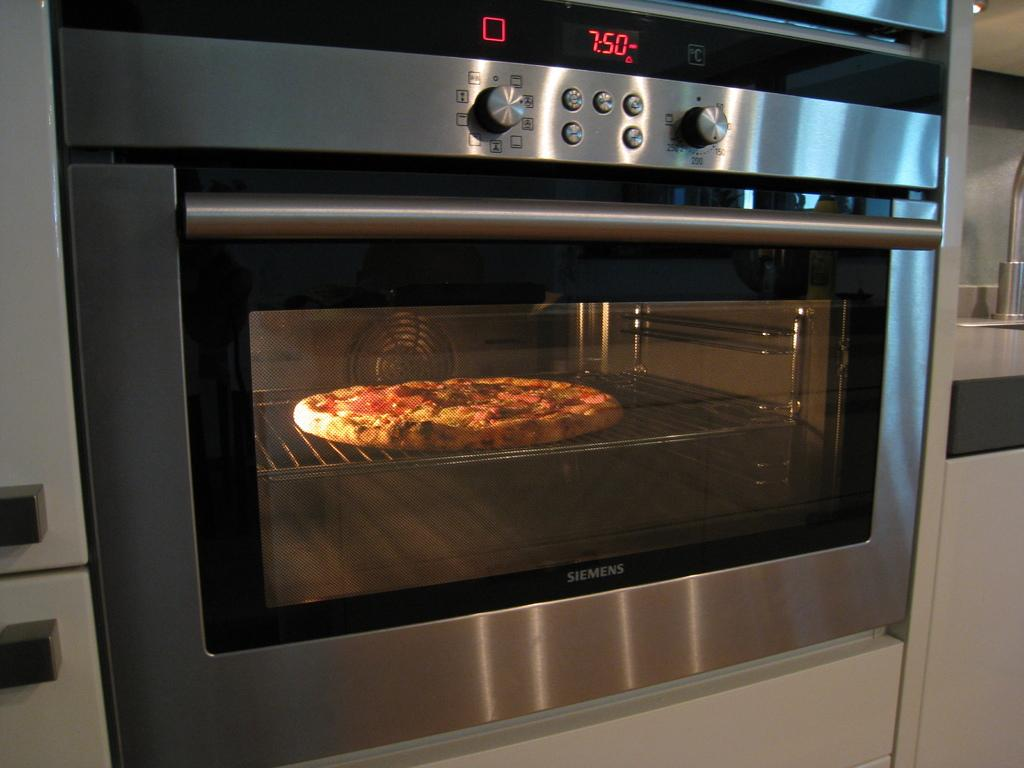<image>
Describe the image concisely. a pizza baking in an oven reading 7:50 